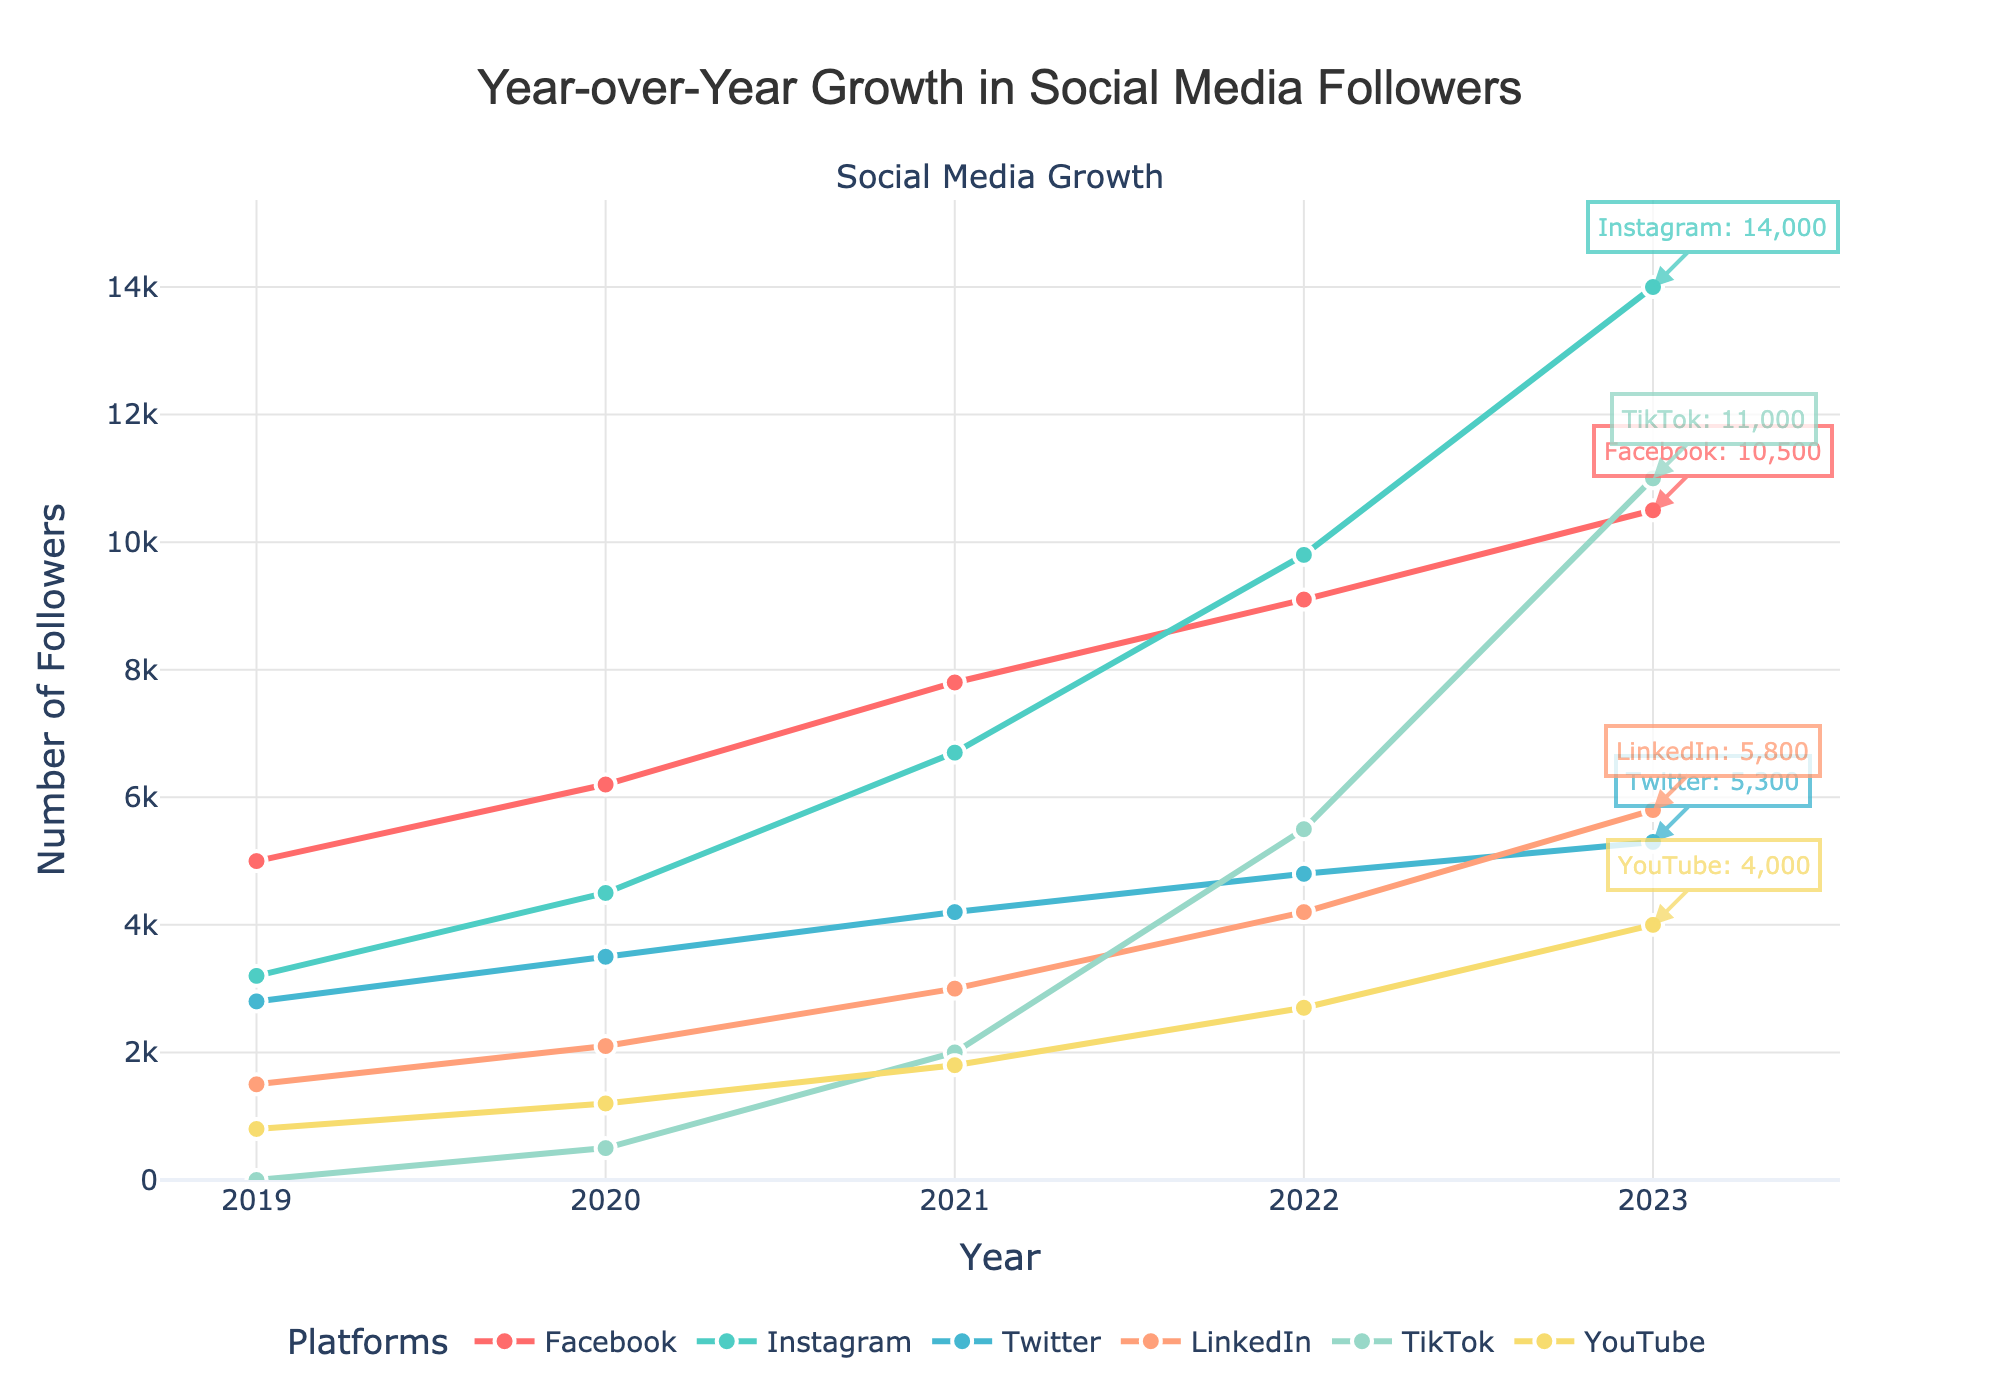Which platform had the highest number of followers in 2023? The chart shows the number of followers for each platform in 2023. TikTok had the highest number of followers with 11,000.
Answer: TikTok Which platform experienced the largest growth from 2019 to 2023? To find the largest growth, we need to compare the increase in followers for each platform between 2019 and 2023. TikTok had the highest growth, going from 0 to 11,000.
Answer: TikTok How does the growth in Instagram followers from 2019 to 2023 compare to the growth in Twitter followers in the same period? Instagram followers increased from 3,200 to 14,000, a growth of 10,800 followers. Twitter followers increased from 2,800 to 5,300, a growth of 2,500 followers. Instagram had a significantly greater increase.
Answer: Instagram had a greater increase What was the total number of followers across all platforms in 2020? Sum the number of followers for all platforms in 2020: 6,200 (Facebook) + 4,500 (Instagram) + 3,500 (Twitter) + 2,100 (LinkedIn) + 500 (TikTok) + 1,200 (YouTube) = 18,000.
Answer: 18,000 Which platform had the steepest increase in followers between consecutive years at any point in the timeline? Identify the steepest increase by examining the year-over-year changes for each platform. TikTok had a steep increase from 2021 (2,000) to 2022 (5,500), a jump of 3,500 followers.
Answer: TikTok In which year did LinkedIn surpass YouTube in followers? Look for the year where LinkedIn followers first exceed YouTube followers: LinkedIn surpassed YouTube in 2020.
Answer: 2020 Which platform showed the most consistent growth over the years? Identify the platform with the most linear or steady increase in followers. Facebook shows a relatively steady increase year-over-year.
Answer: Facebook How many total followers did TikTok have by the end of 2023, and what percentage increase is this compared to its followers in 2021? TikTok had 11,000 followers by the end of 2023, starting with 2,000 in 2021. The increase is 11,000 - 2,000 = 9,000 followers. The percentage increase is (9,000/2,000) * 100% = 450%.
Answer: 450% Which platform had the lowest number of followers in 2019 and how did its follower count change by 2023? In 2019, YouTube had the lowest number of followers with 800. By 2023, YouTube's followers increased to 4,000, showing an increase of 3,200 followers.
Answer: YouTube; increased by 3,200 